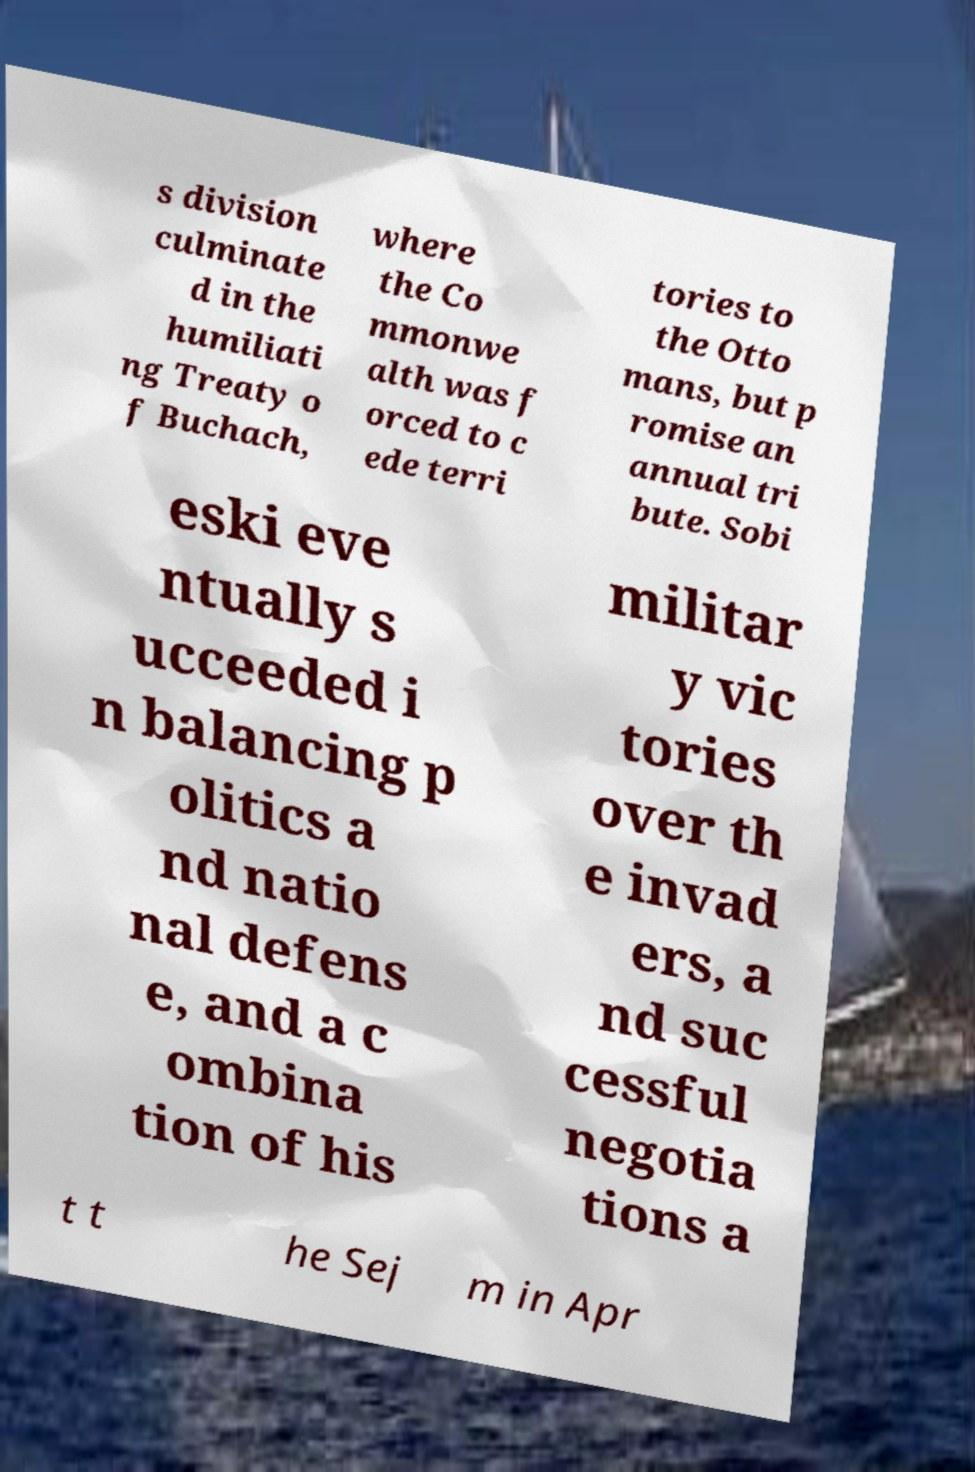Could you extract and type out the text from this image? s division culminate d in the humiliati ng Treaty o f Buchach, where the Co mmonwe alth was f orced to c ede terri tories to the Otto mans, but p romise an annual tri bute. Sobi eski eve ntually s ucceeded i n balancing p olitics a nd natio nal defens e, and a c ombina tion of his militar y vic tories over th e invad ers, a nd suc cessful negotia tions a t t he Sej m in Apr 